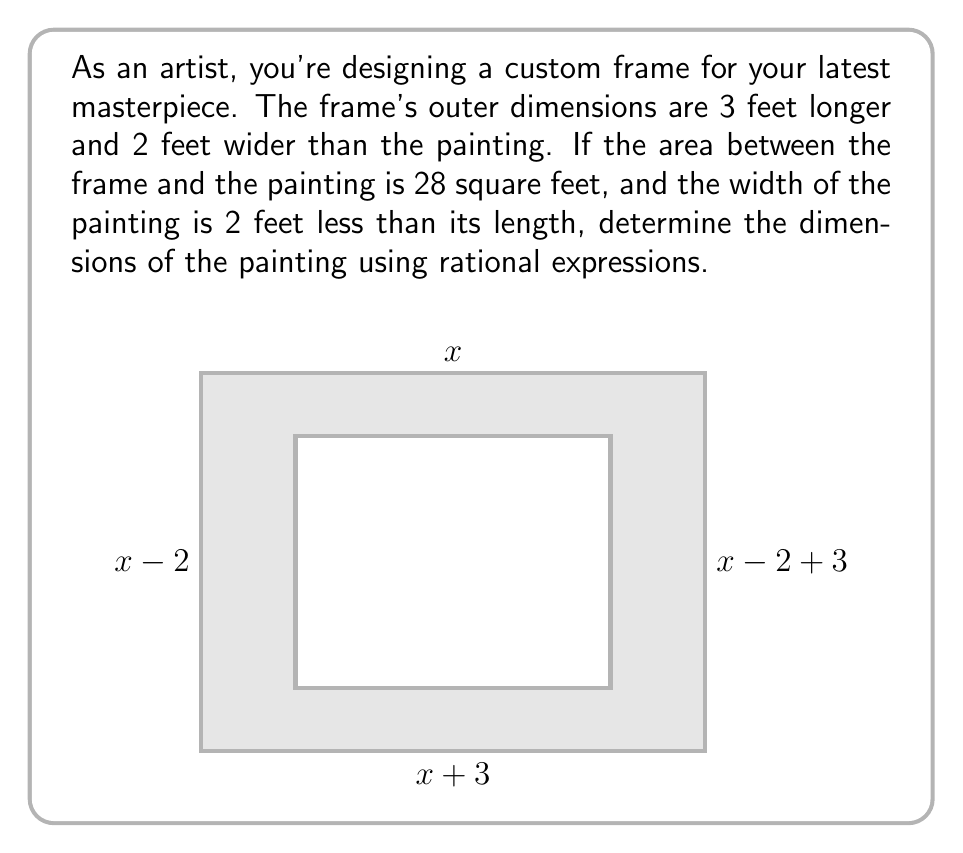Help me with this question. Let's solve this step-by-step:

1) Let $x$ be the length of the painting. Then the width is $x-2$.

2) The outer dimensions of the frame are:
   Length: $x + 3$
   Width: $(x-2) + 2 = x$

3) The area between the frame and the painting is 28 sq ft. We can express this as:
   $$(x+3)(x) - x(x-2) = 28$$

4) Expand the equation:
   $$x^2 + 3x - (x^2 - 2x) = 28$$
   $$x^2 + 3x - x^2 + 2x = 28$$
   $$5x = 28$$

5) Solve for $x$:
   $$x = \frac{28}{5} = 5.6$$

6) The length of the painting is 5.6 feet, and the width is $5.6 - 2 = 3.6$ feet.

7) To verify:
   Area between frame and painting = $(8.6 * 5.6) - (5.6 * 3.6) = 48.16 - 20.16 = 28$ sq ft

Therefore, the dimensions of the painting are 5.6 feet by 3.6 feet.
Answer: $5.6$ ft $\times$ $3.6$ ft 